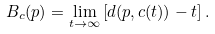Convert formula to latex. <formula><loc_0><loc_0><loc_500><loc_500>B _ { c } ( p ) = \lim _ { t \rightarrow \infty } \left [ d ( p , c ( t ) ) - t \right ] .</formula> 